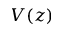Convert formula to latex. <formula><loc_0><loc_0><loc_500><loc_500>V ( z )</formula> 